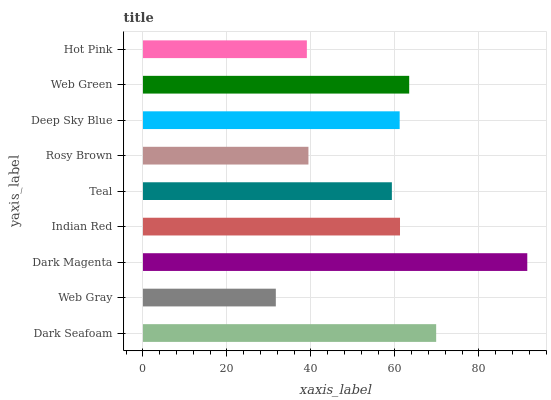Is Web Gray the minimum?
Answer yes or no. Yes. Is Dark Magenta the maximum?
Answer yes or no. Yes. Is Dark Magenta the minimum?
Answer yes or no. No. Is Web Gray the maximum?
Answer yes or no. No. Is Dark Magenta greater than Web Gray?
Answer yes or no. Yes. Is Web Gray less than Dark Magenta?
Answer yes or no. Yes. Is Web Gray greater than Dark Magenta?
Answer yes or no. No. Is Dark Magenta less than Web Gray?
Answer yes or no. No. Is Deep Sky Blue the high median?
Answer yes or no. Yes. Is Deep Sky Blue the low median?
Answer yes or no. Yes. Is Teal the high median?
Answer yes or no. No. Is Dark Magenta the low median?
Answer yes or no. No. 